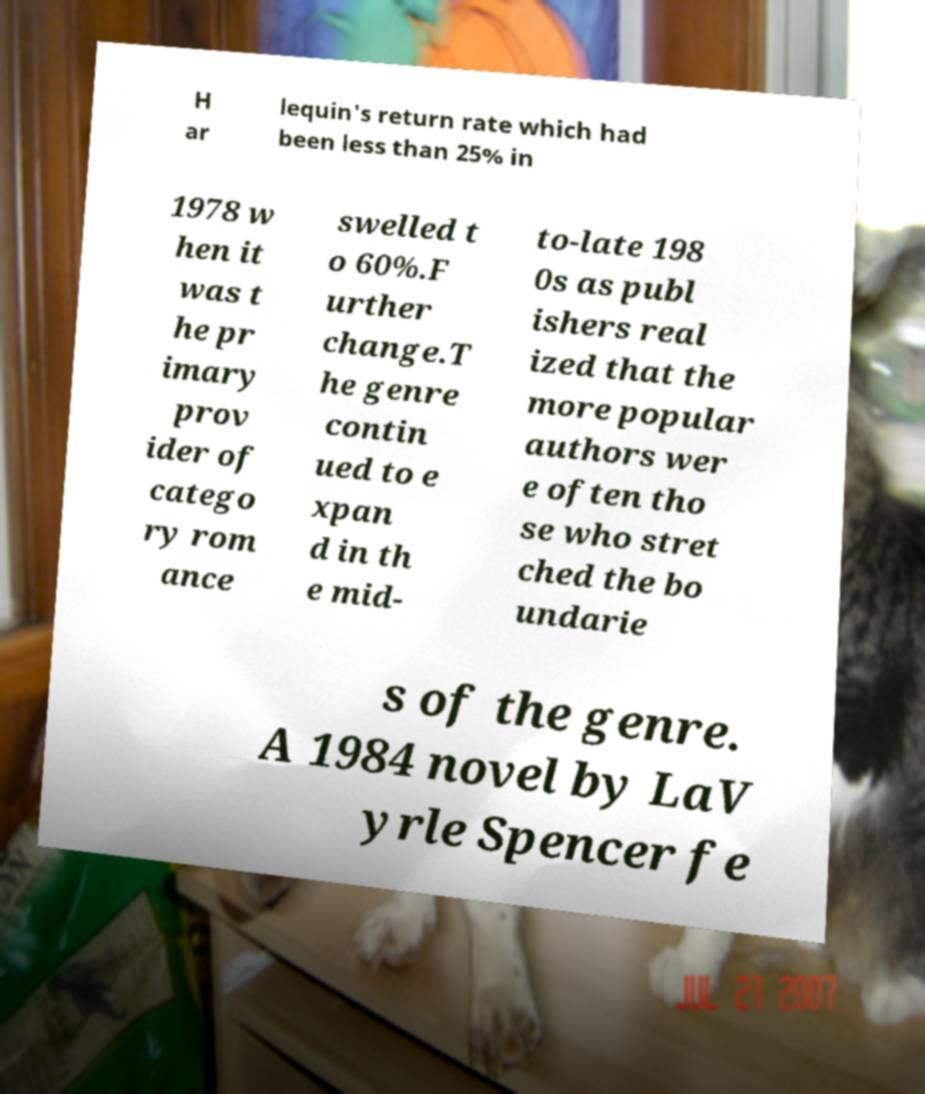I need the written content from this picture converted into text. Can you do that? H ar lequin's return rate which had been less than 25% in 1978 w hen it was t he pr imary prov ider of catego ry rom ance swelled t o 60%.F urther change.T he genre contin ued to e xpan d in th e mid- to-late 198 0s as publ ishers real ized that the more popular authors wer e often tho se who stret ched the bo undarie s of the genre. A 1984 novel by LaV yrle Spencer fe 